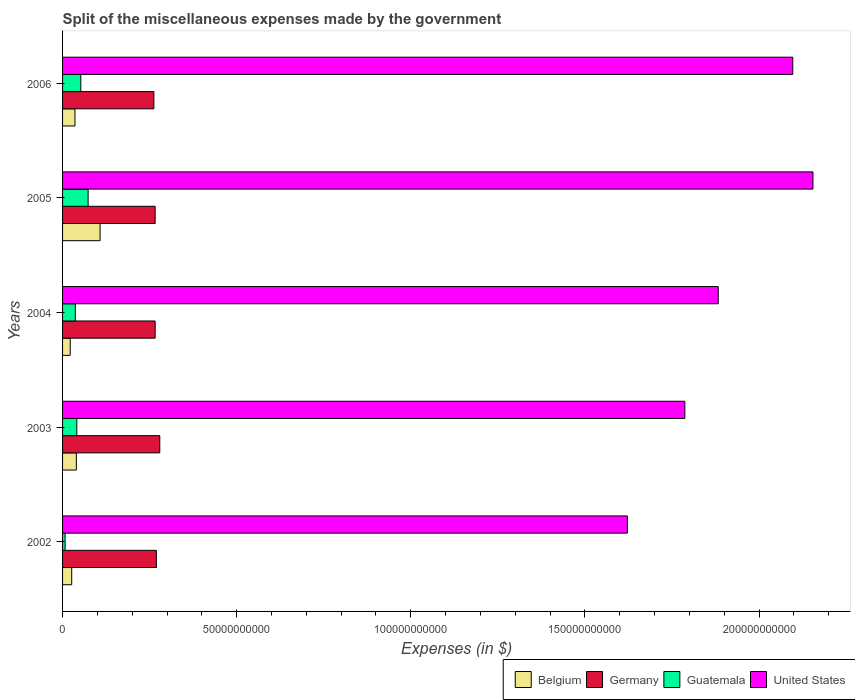How many groups of bars are there?
Offer a very short reply. 5. What is the label of the 5th group of bars from the top?
Offer a terse response. 2002. What is the miscellaneous expenses made by the government in Guatemala in 2006?
Give a very brief answer. 5.24e+09. Across all years, what is the maximum miscellaneous expenses made by the government in Belgium?
Your response must be concise. 1.08e+1. Across all years, what is the minimum miscellaneous expenses made by the government in Germany?
Provide a short and direct response. 2.62e+1. In which year was the miscellaneous expenses made by the government in Belgium maximum?
Offer a terse response. 2005. In which year was the miscellaneous expenses made by the government in United States minimum?
Your answer should be very brief. 2002. What is the total miscellaneous expenses made by the government in Guatemala in the graph?
Give a very brief answer. 2.11e+1. What is the difference between the miscellaneous expenses made by the government in Guatemala in 2002 and that in 2003?
Offer a very short reply. -3.37e+09. What is the difference between the miscellaneous expenses made by the government in Germany in 2005 and the miscellaneous expenses made by the government in Guatemala in 2003?
Provide a short and direct response. 2.25e+1. What is the average miscellaneous expenses made by the government in Germany per year?
Keep it short and to the point. 2.69e+1. In the year 2002, what is the difference between the miscellaneous expenses made by the government in Guatemala and miscellaneous expenses made by the government in Belgium?
Provide a short and direct response. -1.90e+09. In how many years, is the miscellaneous expenses made by the government in Guatemala greater than 160000000000 $?
Offer a terse response. 0. What is the ratio of the miscellaneous expenses made by the government in United States in 2003 to that in 2005?
Ensure brevity in your answer.  0.83. Is the difference between the miscellaneous expenses made by the government in Guatemala in 2005 and 2006 greater than the difference between the miscellaneous expenses made by the government in Belgium in 2005 and 2006?
Provide a short and direct response. No. What is the difference between the highest and the second highest miscellaneous expenses made by the government in Germany?
Make the answer very short. 9.80e+08. What is the difference between the highest and the lowest miscellaneous expenses made by the government in Guatemala?
Provide a succinct answer. 6.61e+09. What does the 2nd bar from the top in 2004 represents?
Offer a terse response. Guatemala. What does the 3rd bar from the bottom in 2005 represents?
Ensure brevity in your answer.  Guatemala. How many bars are there?
Offer a terse response. 20. What is the difference between two consecutive major ticks on the X-axis?
Your answer should be compact. 5.00e+1. Does the graph contain any zero values?
Give a very brief answer. No. Where does the legend appear in the graph?
Make the answer very short. Bottom right. How many legend labels are there?
Offer a terse response. 4. How are the legend labels stacked?
Your answer should be very brief. Horizontal. What is the title of the graph?
Your answer should be compact. Split of the miscellaneous expenses made by the government. What is the label or title of the X-axis?
Provide a short and direct response. Expenses (in $). What is the Expenses (in $) in Belgium in 2002?
Your response must be concise. 2.62e+09. What is the Expenses (in $) in Germany in 2002?
Provide a succinct answer. 2.69e+1. What is the Expenses (in $) in Guatemala in 2002?
Give a very brief answer. 7.27e+08. What is the Expenses (in $) in United States in 2002?
Give a very brief answer. 1.62e+11. What is the Expenses (in $) of Belgium in 2003?
Your answer should be compact. 3.96e+09. What is the Expenses (in $) of Germany in 2003?
Offer a very short reply. 2.79e+1. What is the Expenses (in $) in Guatemala in 2003?
Keep it short and to the point. 4.09e+09. What is the Expenses (in $) of United States in 2003?
Your answer should be very brief. 1.79e+11. What is the Expenses (in $) of Belgium in 2004?
Offer a very short reply. 2.19e+09. What is the Expenses (in $) of Germany in 2004?
Provide a short and direct response. 2.66e+1. What is the Expenses (in $) in Guatemala in 2004?
Provide a short and direct response. 3.67e+09. What is the Expenses (in $) in United States in 2004?
Give a very brief answer. 1.88e+11. What is the Expenses (in $) in Belgium in 2005?
Keep it short and to the point. 1.08e+1. What is the Expenses (in $) in Germany in 2005?
Provide a short and direct response. 2.66e+1. What is the Expenses (in $) in Guatemala in 2005?
Offer a very short reply. 7.34e+09. What is the Expenses (in $) in United States in 2005?
Your response must be concise. 2.16e+11. What is the Expenses (in $) in Belgium in 2006?
Offer a very short reply. 3.56e+09. What is the Expenses (in $) of Germany in 2006?
Offer a terse response. 2.62e+1. What is the Expenses (in $) in Guatemala in 2006?
Ensure brevity in your answer.  5.24e+09. What is the Expenses (in $) of United States in 2006?
Ensure brevity in your answer.  2.10e+11. Across all years, what is the maximum Expenses (in $) of Belgium?
Provide a short and direct response. 1.08e+1. Across all years, what is the maximum Expenses (in $) of Germany?
Make the answer very short. 2.79e+1. Across all years, what is the maximum Expenses (in $) of Guatemala?
Your answer should be compact. 7.34e+09. Across all years, what is the maximum Expenses (in $) of United States?
Give a very brief answer. 2.16e+11. Across all years, what is the minimum Expenses (in $) in Belgium?
Make the answer very short. 2.19e+09. Across all years, what is the minimum Expenses (in $) in Germany?
Keep it short and to the point. 2.62e+1. Across all years, what is the minimum Expenses (in $) in Guatemala?
Keep it short and to the point. 7.27e+08. Across all years, what is the minimum Expenses (in $) of United States?
Offer a very short reply. 1.62e+11. What is the total Expenses (in $) in Belgium in the graph?
Offer a very short reply. 2.31e+1. What is the total Expenses (in $) in Germany in the graph?
Keep it short and to the point. 1.34e+11. What is the total Expenses (in $) of Guatemala in the graph?
Ensure brevity in your answer.  2.11e+1. What is the total Expenses (in $) in United States in the graph?
Ensure brevity in your answer.  9.54e+11. What is the difference between the Expenses (in $) of Belgium in 2002 and that in 2003?
Your answer should be very brief. -1.33e+09. What is the difference between the Expenses (in $) in Germany in 2002 and that in 2003?
Provide a short and direct response. -9.80e+08. What is the difference between the Expenses (in $) in Guatemala in 2002 and that in 2003?
Provide a succinct answer. -3.37e+09. What is the difference between the Expenses (in $) of United States in 2002 and that in 2003?
Ensure brevity in your answer.  -1.65e+1. What is the difference between the Expenses (in $) in Belgium in 2002 and that in 2004?
Your answer should be compact. 4.30e+08. What is the difference between the Expenses (in $) of Germany in 2002 and that in 2004?
Provide a short and direct response. 3.50e+08. What is the difference between the Expenses (in $) in Guatemala in 2002 and that in 2004?
Provide a short and direct response. -2.94e+09. What is the difference between the Expenses (in $) of United States in 2002 and that in 2004?
Offer a very short reply. -2.61e+1. What is the difference between the Expenses (in $) in Belgium in 2002 and that in 2005?
Offer a very short reply. -8.14e+09. What is the difference between the Expenses (in $) in Germany in 2002 and that in 2005?
Provide a short and direct response. 3.50e+08. What is the difference between the Expenses (in $) of Guatemala in 2002 and that in 2005?
Your answer should be very brief. -6.61e+09. What is the difference between the Expenses (in $) of United States in 2002 and that in 2005?
Your answer should be compact. -5.33e+1. What is the difference between the Expenses (in $) in Belgium in 2002 and that in 2006?
Provide a short and direct response. -9.39e+08. What is the difference between the Expenses (in $) of Germany in 2002 and that in 2006?
Provide a succinct answer. 7.20e+08. What is the difference between the Expenses (in $) of Guatemala in 2002 and that in 2006?
Your response must be concise. -4.51e+09. What is the difference between the Expenses (in $) of United States in 2002 and that in 2006?
Offer a terse response. -4.75e+1. What is the difference between the Expenses (in $) of Belgium in 2003 and that in 2004?
Ensure brevity in your answer.  1.76e+09. What is the difference between the Expenses (in $) in Germany in 2003 and that in 2004?
Your answer should be very brief. 1.33e+09. What is the difference between the Expenses (in $) in Guatemala in 2003 and that in 2004?
Provide a succinct answer. 4.25e+08. What is the difference between the Expenses (in $) in United States in 2003 and that in 2004?
Make the answer very short. -9.60e+09. What is the difference between the Expenses (in $) in Belgium in 2003 and that in 2005?
Offer a terse response. -6.81e+09. What is the difference between the Expenses (in $) of Germany in 2003 and that in 2005?
Provide a short and direct response. 1.33e+09. What is the difference between the Expenses (in $) of Guatemala in 2003 and that in 2005?
Your answer should be very brief. -3.24e+09. What is the difference between the Expenses (in $) in United States in 2003 and that in 2005?
Keep it short and to the point. -3.68e+1. What is the difference between the Expenses (in $) of Belgium in 2003 and that in 2006?
Provide a succinct answer. 3.94e+08. What is the difference between the Expenses (in $) of Germany in 2003 and that in 2006?
Offer a terse response. 1.70e+09. What is the difference between the Expenses (in $) of Guatemala in 2003 and that in 2006?
Give a very brief answer. -1.14e+09. What is the difference between the Expenses (in $) in United States in 2003 and that in 2006?
Make the answer very short. -3.10e+1. What is the difference between the Expenses (in $) in Belgium in 2004 and that in 2005?
Offer a very short reply. -8.57e+09. What is the difference between the Expenses (in $) of Germany in 2004 and that in 2005?
Your response must be concise. 0. What is the difference between the Expenses (in $) in Guatemala in 2004 and that in 2005?
Your response must be concise. -3.67e+09. What is the difference between the Expenses (in $) of United States in 2004 and that in 2005?
Provide a succinct answer. -2.72e+1. What is the difference between the Expenses (in $) in Belgium in 2004 and that in 2006?
Make the answer very short. -1.37e+09. What is the difference between the Expenses (in $) of Germany in 2004 and that in 2006?
Provide a succinct answer. 3.70e+08. What is the difference between the Expenses (in $) of Guatemala in 2004 and that in 2006?
Provide a succinct answer. -1.57e+09. What is the difference between the Expenses (in $) in United States in 2004 and that in 2006?
Your answer should be very brief. -2.14e+1. What is the difference between the Expenses (in $) of Belgium in 2005 and that in 2006?
Provide a succinct answer. 7.20e+09. What is the difference between the Expenses (in $) in Germany in 2005 and that in 2006?
Offer a terse response. 3.70e+08. What is the difference between the Expenses (in $) in Guatemala in 2005 and that in 2006?
Make the answer very short. 2.10e+09. What is the difference between the Expenses (in $) in United States in 2005 and that in 2006?
Offer a very short reply. 5.80e+09. What is the difference between the Expenses (in $) of Belgium in 2002 and the Expenses (in $) of Germany in 2003?
Offer a very short reply. -2.53e+1. What is the difference between the Expenses (in $) in Belgium in 2002 and the Expenses (in $) in Guatemala in 2003?
Offer a very short reply. -1.47e+09. What is the difference between the Expenses (in $) of Belgium in 2002 and the Expenses (in $) of United States in 2003?
Make the answer very short. -1.76e+11. What is the difference between the Expenses (in $) in Germany in 2002 and the Expenses (in $) in Guatemala in 2003?
Offer a terse response. 2.28e+1. What is the difference between the Expenses (in $) in Germany in 2002 and the Expenses (in $) in United States in 2003?
Give a very brief answer. -1.52e+11. What is the difference between the Expenses (in $) in Guatemala in 2002 and the Expenses (in $) in United States in 2003?
Give a very brief answer. -1.78e+11. What is the difference between the Expenses (in $) in Belgium in 2002 and the Expenses (in $) in Germany in 2004?
Ensure brevity in your answer.  -2.40e+1. What is the difference between the Expenses (in $) of Belgium in 2002 and the Expenses (in $) of Guatemala in 2004?
Your answer should be very brief. -1.04e+09. What is the difference between the Expenses (in $) of Belgium in 2002 and the Expenses (in $) of United States in 2004?
Offer a terse response. -1.86e+11. What is the difference between the Expenses (in $) of Germany in 2002 and the Expenses (in $) of Guatemala in 2004?
Give a very brief answer. 2.33e+1. What is the difference between the Expenses (in $) in Germany in 2002 and the Expenses (in $) in United States in 2004?
Make the answer very short. -1.61e+11. What is the difference between the Expenses (in $) in Guatemala in 2002 and the Expenses (in $) in United States in 2004?
Provide a succinct answer. -1.88e+11. What is the difference between the Expenses (in $) in Belgium in 2002 and the Expenses (in $) in Germany in 2005?
Offer a very short reply. -2.40e+1. What is the difference between the Expenses (in $) of Belgium in 2002 and the Expenses (in $) of Guatemala in 2005?
Your answer should be very brief. -4.71e+09. What is the difference between the Expenses (in $) of Belgium in 2002 and the Expenses (in $) of United States in 2005?
Your answer should be compact. -2.13e+11. What is the difference between the Expenses (in $) of Germany in 2002 and the Expenses (in $) of Guatemala in 2005?
Make the answer very short. 1.96e+1. What is the difference between the Expenses (in $) of Germany in 2002 and the Expenses (in $) of United States in 2005?
Your answer should be compact. -1.89e+11. What is the difference between the Expenses (in $) of Guatemala in 2002 and the Expenses (in $) of United States in 2005?
Give a very brief answer. -2.15e+11. What is the difference between the Expenses (in $) in Belgium in 2002 and the Expenses (in $) in Germany in 2006?
Your answer should be compact. -2.36e+1. What is the difference between the Expenses (in $) in Belgium in 2002 and the Expenses (in $) in Guatemala in 2006?
Offer a very short reply. -2.61e+09. What is the difference between the Expenses (in $) of Belgium in 2002 and the Expenses (in $) of United States in 2006?
Provide a succinct answer. -2.07e+11. What is the difference between the Expenses (in $) of Germany in 2002 and the Expenses (in $) of Guatemala in 2006?
Your answer should be very brief. 2.17e+1. What is the difference between the Expenses (in $) of Germany in 2002 and the Expenses (in $) of United States in 2006?
Your response must be concise. -1.83e+11. What is the difference between the Expenses (in $) in Guatemala in 2002 and the Expenses (in $) in United States in 2006?
Offer a very short reply. -2.09e+11. What is the difference between the Expenses (in $) in Belgium in 2003 and the Expenses (in $) in Germany in 2004?
Your response must be concise. -2.26e+1. What is the difference between the Expenses (in $) of Belgium in 2003 and the Expenses (in $) of Guatemala in 2004?
Make the answer very short. 2.90e+08. What is the difference between the Expenses (in $) in Belgium in 2003 and the Expenses (in $) in United States in 2004?
Your answer should be compact. -1.84e+11. What is the difference between the Expenses (in $) in Germany in 2003 and the Expenses (in $) in Guatemala in 2004?
Provide a short and direct response. 2.43e+1. What is the difference between the Expenses (in $) of Germany in 2003 and the Expenses (in $) of United States in 2004?
Your response must be concise. -1.60e+11. What is the difference between the Expenses (in $) of Guatemala in 2003 and the Expenses (in $) of United States in 2004?
Your answer should be compact. -1.84e+11. What is the difference between the Expenses (in $) of Belgium in 2003 and the Expenses (in $) of Germany in 2005?
Keep it short and to the point. -2.26e+1. What is the difference between the Expenses (in $) of Belgium in 2003 and the Expenses (in $) of Guatemala in 2005?
Offer a very short reply. -3.38e+09. What is the difference between the Expenses (in $) of Belgium in 2003 and the Expenses (in $) of United States in 2005?
Give a very brief answer. -2.12e+11. What is the difference between the Expenses (in $) of Germany in 2003 and the Expenses (in $) of Guatemala in 2005?
Offer a terse response. 2.06e+1. What is the difference between the Expenses (in $) in Germany in 2003 and the Expenses (in $) in United States in 2005?
Provide a short and direct response. -1.88e+11. What is the difference between the Expenses (in $) in Guatemala in 2003 and the Expenses (in $) in United States in 2005?
Offer a terse response. -2.11e+11. What is the difference between the Expenses (in $) of Belgium in 2003 and the Expenses (in $) of Germany in 2006?
Give a very brief answer. -2.23e+1. What is the difference between the Expenses (in $) in Belgium in 2003 and the Expenses (in $) in Guatemala in 2006?
Ensure brevity in your answer.  -1.28e+09. What is the difference between the Expenses (in $) in Belgium in 2003 and the Expenses (in $) in United States in 2006?
Make the answer very short. -2.06e+11. What is the difference between the Expenses (in $) of Germany in 2003 and the Expenses (in $) of Guatemala in 2006?
Offer a very short reply. 2.27e+1. What is the difference between the Expenses (in $) in Germany in 2003 and the Expenses (in $) in United States in 2006?
Offer a very short reply. -1.82e+11. What is the difference between the Expenses (in $) in Guatemala in 2003 and the Expenses (in $) in United States in 2006?
Offer a very short reply. -2.06e+11. What is the difference between the Expenses (in $) of Belgium in 2004 and the Expenses (in $) of Germany in 2005?
Offer a terse response. -2.44e+1. What is the difference between the Expenses (in $) in Belgium in 2004 and the Expenses (in $) in Guatemala in 2005?
Keep it short and to the point. -5.14e+09. What is the difference between the Expenses (in $) in Belgium in 2004 and the Expenses (in $) in United States in 2005?
Provide a succinct answer. -2.13e+11. What is the difference between the Expenses (in $) of Germany in 2004 and the Expenses (in $) of Guatemala in 2005?
Give a very brief answer. 1.93e+1. What is the difference between the Expenses (in $) of Germany in 2004 and the Expenses (in $) of United States in 2005?
Ensure brevity in your answer.  -1.89e+11. What is the difference between the Expenses (in $) of Guatemala in 2004 and the Expenses (in $) of United States in 2005?
Keep it short and to the point. -2.12e+11. What is the difference between the Expenses (in $) of Belgium in 2004 and the Expenses (in $) of Germany in 2006?
Offer a terse response. -2.40e+1. What is the difference between the Expenses (in $) of Belgium in 2004 and the Expenses (in $) of Guatemala in 2006?
Your answer should be very brief. -3.04e+09. What is the difference between the Expenses (in $) in Belgium in 2004 and the Expenses (in $) in United States in 2006?
Keep it short and to the point. -2.08e+11. What is the difference between the Expenses (in $) in Germany in 2004 and the Expenses (in $) in Guatemala in 2006?
Give a very brief answer. 2.14e+1. What is the difference between the Expenses (in $) in Germany in 2004 and the Expenses (in $) in United States in 2006?
Your answer should be very brief. -1.83e+11. What is the difference between the Expenses (in $) in Guatemala in 2004 and the Expenses (in $) in United States in 2006?
Offer a very short reply. -2.06e+11. What is the difference between the Expenses (in $) of Belgium in 2005 and the Expenses (in $) of Germany in 2006?
Your answer should be very brief. -1.55e+1. What is the difference between the Expenses (in $) of Belgium in 2005 and the Expenses (in $) of Guatemala in 2006?
Provide a short and direct response. 5.53e+09. What is the difference between the Expenses (in $) of Belgium in 2005 and the Expenses (in $) of United States in 2006?
Your answer should be very brief. -1.99e+11. What is the difference between the Expenses (in $) of Germany in 2005 and the Expenses (in $) of Guatemala in 2006?
Provide a succinct answer. 2.14e+1. What is the difference between the Expenses (in $) in Germany in 2005 and the Expenses (in $) in United States in 2006?
Provide a short and direct response. -1.83e+11. What is the difference between the Expenses (in $) in Guatemala in 2005 and the Expenses (in $) in United States in 2006?
Keep it short and to the point. -2.02e+11. What is the average Expenses (in $) of Belgium per year?
Keep it short and to the point. 4.62e+09. What is the average Expenses (in $) in Germany per year?
Your answer should be very brief. 2.69e+1. What is the average Expenses (in $) of Guatemala per year?
Give a very brief answer. 4.21e+09. What is the average Expenses (in $) in United States per year?
Make the answer very short. 1.91e+11. In the year 2002, what is the difference between the Expenses (in $) in Belgium and Expenses (in $) in Germany?
Your response must be concise. -2.43e+1. In the year 2002, what is the difference between the Expenses (in $) in Belgium and Expenses (in $) in Guatemala?
Offer a terse response. 1.90e+09. In the year 2002, what is the difference between the Expenses (in $) in Belgium and Expenses (in $) in United States?
Offer a very short reply. -1.60e+11. In the year 2002, what is the difference between the Expenses (in $) of Germany and Expenses (in $) of Guatemala?
Offer a very short reply. 2.62e+1. In the year 2002, what is the difference between the Expenses (in $) in Germany and Expenses (in $) in United States?
Make the answer very short. -1.35e+11. In the year 2002, what is the difference between the Expenses (in $) in Guatemala and Expenses (in $) in United States?
Ensure brevity in your answer.  -1.61e+11. In the year 2003, what is the difference between the Expenses (in $) of Belgium and Expenses (in $) of Germany?
Ensure brevity in your answer.  -2.40e+1. In the year 2003, what is the difference between the Expenses (in $) of Belgium and Expenses (in $) of Guatemala?
Offer a terse response. -1.35e+08. In the year 2003, what is the difference between the Expenses (in $) of Belgium and Expenses (in $) of United States?
Provide a short and direct response. -1.75e+11. In the year 2003, what is the difference between the Expenses (in $) of Germany and Expenses (in $) of Guatemala?
Ensure brevity in your answer.  2.38e+1. In the year 2003, what is the difference between the Expenses (in $) of Germany and Expenses (in $) of United States?
Make the answer very short. -1.51e+11. In the year 2003, what is the difference between the Expenses (in $) of Guatemala and Expenses (in $) of United States?
Provide a short and direct response. -1.75e+11. In the year 2004, what is the difference between the Expenses (in $) in Belgium and Expenses (in $) in Germany?
Make the answer very short. -2.44e+1. In the year 2004, what is the difference between the Expenses (in $) in Belgium and Expenses (in $) in Guatemala?
Your answer should be compact. -1.47e+09. In the year 2004, what is the difference between the Expenses (in $) of Belgium and Expenses (in $) of United States?
Provide a short and direct response. -1.86e+11. In the year 2004, what is the difference between the Expenses (in $) in Germany and Expenses (in $) in Guatemala?
Offer a very short reply. 2.29e+1. In the year 2004, what is the difference between the Expenses (in $) in Germany and Expenses (in $) in United States?
Give a very brief answer. -1.62e+11. In the year 2004, what is the difference between the Expenses (in $) of Guatemala and Expenses (in $) of United States?
Ensure brevity in your answer.  -1.85e+11. In the year 2005, what is the difference between the Expenses (in $) of Belgium and Expenses (in $) of Germany?
Provide a short and direct response. -1.58e+1. In the year 2005, what is the difference between the Expenses (in $) in Belgium and Expenses (in $) in Guatemala?
Offer a very short reply. 3.43e+09. In the year 2005, what is the difference between the Expenses (in $) of Belgium and Expenses (in $) of United States?
Give a very brief answer. -2.05e+11. In the year 2005, what is the difference between the Expenses (in $) in Germany and Expenses (in $) in Guatemala?
Your answer should be compact. 1.93e+1. In the year 2005, what is the difference between the Expenses (in $) of Germany and Expenses (in $) of United States?
Make the answer very short. -1.89e+11. In the year 2005, what is the difference between the Expenses (in $) in Guatemala and Expenses (in $) in United States?
Provide a short and direct response. -2.08e+11. In the year 2006, what is the difference between the Expenses (in $) of Belgium and Expenses (in $) of Germany?
Provide a succinct answer. -2.27e+1. In the year 2006, what is the difference between the Expenses (in $) of Belgium and Expenses (in $) of Guatemala?
Provide a short and direct response. -1.67e+09. In the year 2006, what is the difference between the Expenses (in $) in Belgium and Expenses (in $) in United States?
Provide a succinct answer. -2.06e+11. In the year 2006, what is the difference between the Expenses (in $) of Germany and Expenses (in $) of Guatemala?
Your answer should be compact. 2.10e+1. In the year 2006, what is the difference between the Expenses (in $) of Germany and Expenses (in $) of United States?
Offer a very short reply. -1.83e+11. In the year 2006, what is the difference between the Expenses (in $) of Guatemala and Expenses (in $) of United States?
Provide a succinct answer. -2.04e+11. What is the ratio of the Expenses (in $) of Belgium in 2002 to that in 2003?
Offer a very short reply. 0.66. What is the ratio of the Expenses (in $) of Germany in 2002 to that in 2003?
Your answer should be very brief. 0.96. What is the ratio of the Expenses (in $) of Guatemala in 2002 to that in 2003?
Offer a terse response. 0.18. What is the ratio of the Expenses (in $) in United States in 2002 to that in 2003?
Provide a short and direct response. 0.91. What is the ratio of the Expenses (in $) in Belgium in 2002 to that in 2004?
Your response must be concise. 1.2. What is the ratio of the Expenses (in $) in Germany in 2002 to that in 2004?
Provide a short and direct response. 1.01. What is the ratio of the Expenses (in $) of Guatemala in 2002 to that in 2004?
Make the answer very short. 0.2. What is the ratio of the Expenses (in $) of United States in 2002 to that in 2004?
Give a very brief answer. 0.86. What is the ratio of the Expenses (in $) in Belgium in 2002 to that in 2005?
Your response must be concise. 0.24. What is the ratio of the Expenses (in $) in Germany in 2002 to that in 2005?
Give a very brief answer. 1.01. What is the ratio of the Expenses (in $) of Guatemala in 2002 to that in 2005?
Your answer should be compact. 0.1. What is the ratio of the Expenses (in $) in United States in 2002 to that in 2005?
Ensure brevity in your answer.  0.75. What is the ratio of the Expenses (in $) in Belgium in 2002 to that in 2006?
Ensure brevity in your answer.  0.74. What is the ratio of the Expenses (in $) in Germany in 2002 to that in 2006?
Give a very brief answer. 1.03. What is the ratio of the Expenses (in $) of Guatemala in 2002 to that in 2006?
Offer a very short reply. 0.14. What is the ratio of the Expenses (in $) of United States in 2002 to that in 2006?
Offer a very short reply. 0.77. What is the ratio of the Expenses (in $) in Belgium in 2003 to that in 2004?
Ensure brevity in your answer.  1.8. What is the ratio of the Expenses (in $) of Germany in 2003 to that in 2004?
Provide a succinct answer. 1.05. What is the ratio of the Expenses (in $) in Guatemala in 2003 to that in 2004?
Your response must be concise. 1.12. What is the ratio of the Expenses (in $) of United States in 2003 to that in 2004?
Give a very brief answer. 0.95. What is the ratio of the Expenses (in $) of Belgium in 2003 to that in 2005?
Provide a short and direct response. 0.37. What is the ratio of the Expenses (in $) in Guatemala in 2003 to that in 2005?
Ensure brevity in your answer.  0.56. What is the ratio of the Expenses (in $) of United States in 2003 to that in 2005?
Make the answer very short. 0.83. What is the ratio of the Expenses (in $) of Belgium in 2003 to that in 2006?
Make the answer very short. 1.11. What is the ratio of the Expenses (in $) of Germany in 2003 to that in 2006?
Your answer should be compact. 1.06. What is the ratio of the Expenses (in $) in Guatemala in 2003 to that in 2006?
Your response must be concise. 0.78. What is the ratio of the Expenses (in $) of United States in 2003 to that in 2006?
Offer a terse response. 0.85. What is the ratio of the Expenses (in $) in Belgium in 2004 to that in 2005?
Your answer should be very brief. 0.2. What is the ratio of the Expenses (in $) in Germany in 2004 to that in 2005?
Your answer should be very brief. 1. What is the ratio of the Expenses (in $) in Guatemala in 2004 to that in 2005?
Provide a succinct answer. 0.5. What is the ratio of the Expenses (in $) in United States in 2004 to that in 2005?
Offer a very short reply. 0.87. What is the ratio of the Expenses (in $) of Belgium in 2004 to that in 2006?
Your answer should be very brief. 0.62. What is the ratio of the Expenses (in $) in Germany in 2004 to that in 2006?
Keep it short and to the point. 1.01. What is the ratio of the Expenses (in $) of Guatemala in 2004 to that in 2006?
Make the answer very short. 0.7. What is the ratio of the Expenses (in $) in United States in 2004 to that in 2006?
Provide a short and direct response. 0.9. What is the ratio of the Expenses (in $) of Belgium in 2005 to that in 2006?
Give a very brief answer. 3.02. What is the ratio of the Expenses (in $) in Germany in 2005 to that in 2006?
Your answer should be very brief. 1.01. What is the ratio of the Expenses (in $) of Guatemala in 2005 to that in 2006?
Keep it short and to the point. 1.4. What is the ratio of the Expenses (in $) in United States in 2005 to that in 2006?
Offer a terse response. 1.03. What is the difference between the highest and the second highest Expenses (in $) in Belgium?
Give a very brief answer. 6.81e+09. What is the difference between the highest and the second highest Expenses (in $) in Germany?
Make the answer very short. 9.80e+08. What is the difference between the highest and the second highest Expenses (in $) of Guatemala?
Keep it short and to the point. 2.10e+09. What is the difference between the highest and the second highest Expenses (in $) in United States?
Give a very brief answer. 5.80e+09. What is the difference between the highest and the lowest Expenses (in $) of Belgium?
Your answer should be very brief. 8.57e+09. What is the difference between the highest and the lowest Expenses (in $) in Germany?
Make the answer very short. 1.70e+09. What is the difference between the highest and the lowest Expenses (in $) in Guatemala?
Provide a short and direct response. 6.61e+09. What is the difference between the highest and the lowest Expenses (in $) of United States?
Your answer should be compact. 5.33e+1. 